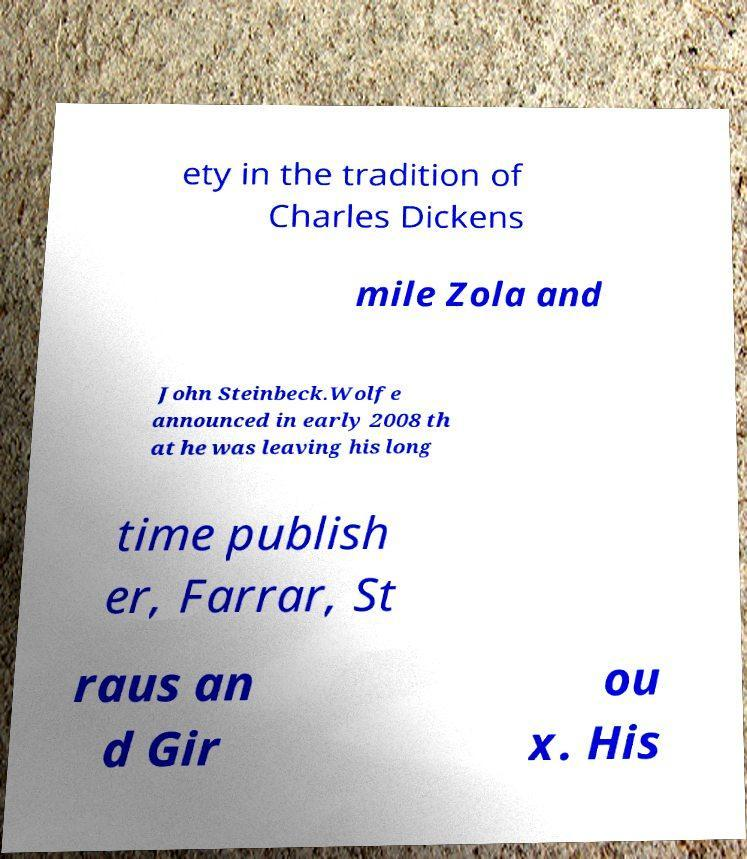What messages or text are displayed in this image? I need them in a readable, typed format. ety in the tradition of Charles Dickens mile Zola and John Steinbeck.Wolfe announced in early 2008 th at he was leaving his long time publish er, Farrar, St raus an d Gir ou x. His 